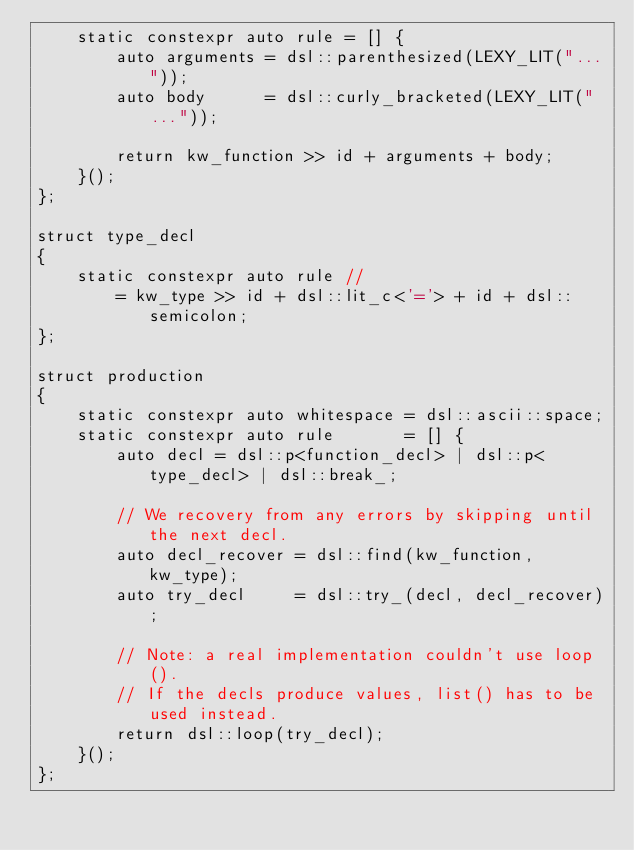<code> <loc_0><loc_0><loc_500><loc_500><_C++_>    static constexpr auto rule = [] {
        auto arguments = dsl::parenthesized(LEXY_LIT("..."));
        auto body      = dsl::curly_bracketed(LEXY_LIT("..."));

        return kw_function >> id + arguments + body;
    }();
};

struct type_decl
{
    static constexpr auto rule //
        = kw_type >> id + dsl::lit_c<'='> + id + dsl::semicolon;
};

struct production
{
    static constexpr auto whitespace = dsl::ascii::space;
    static constexpr auto rule       = [] {
        auto decl = dsl::p<function_decl> | dsl::p<type_decl> | dsl::break_;

        // We recovery from any errors by skipping until the next decl.
        auto decl_recover = dsl::find(kw_function, kw_type);
        auto try_decl     = dsl::try_(decl, decl_recover);

        // Note: a real implementation couldn't use loop().
        // If the decls produce values, list() has to be used instead.
        return dsl::loop(try_decl);
    }();
};
</code> 